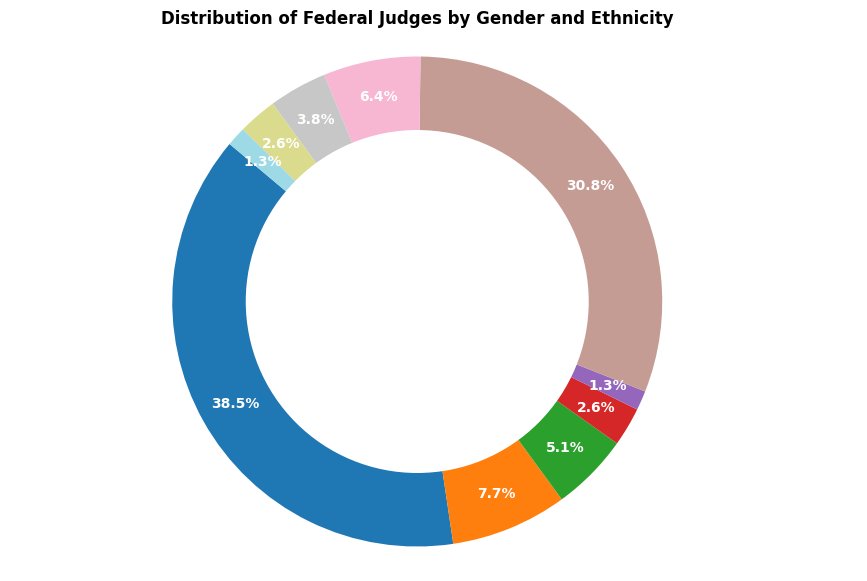What percentage of federal judges are white females? To find the percentage of white female judges, locate the "Female - White" segment from the pie chart and read off the percentage displayed on the chart.
Answer: 38.9% Which category of federal judges has the smallest representation? Scan through all the segments of the pie chart to find the one with the smallest slice.
Answer: Male - Other What is the combined percentage of Hispanic judges, both male and female? Sum the percentages of the "Male - Hispanic" and "Female - Hispanic" segments from the pie chart.
Answer: 7.0% Which gender has a higher percentage representation among federal judges, and by how much? Compare the combined percentages of all male categories and all female categories, then calculate the difference. Male: 150 + 30 + 20 + 10 + 5 = 215 (61.4%); Female: 120 + 25 + 15 + 10 + 5 = 175 (50.0%)
Answer: Male, by 11.4% Are there more white female judges or African American male judges? Compare the slices labeled "Female - White" and "Male - African American" to see which has a larger percentage.
Answer: White female judges What is the difference in percentage between African American male judges and African American female judges? Subtract the percentage of "Female - African American" from "Male - African American" as shown on the pie chart.
Answer: 3.5% What is the combined percentage of Asian American judges, both male and female? Add the percentages of the "Male - Asian American" and "Female - Asian American" segments from the pie chart.
Answer: 5.7% Which ethnic group has the largest difference in representation between males and females? For each ethnic group, calculate the difference between the male and female percentages, then identify the largest difference.
Answer: White (10.6%) What is the overall percentage of female judges of any ethnicity? Sum the percentages of all female categories displayed on the pie chart.
Answer: 50.0% What is the difference in representation between White male judges and the total of Other judges (both male and female)? Calculate the percentage of "White - Male" judges and subtract the combined percentage of "Other - Male" and "Other - Female" judges. White Male: 42.9%; Other: 3.6%
Answer: 39.3% 